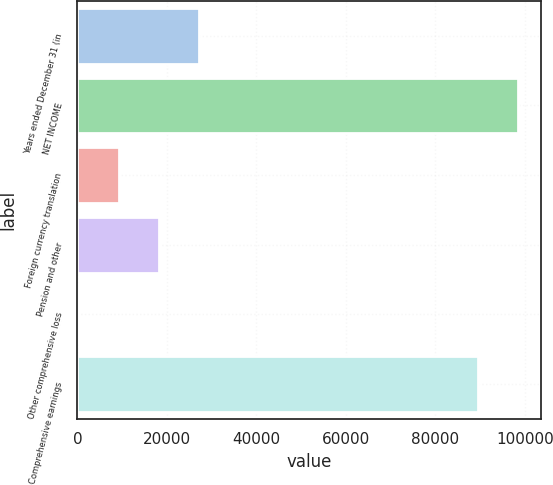<chart> <loc_0><loc_0><loc_500><loc_500><bar_chart><fcel>Years ended December 31 (in<fcel>NET INCOME<fcel>Foreign currency translation<fcel>Pension and other<fcel>Other comprehensive loss<fcel>Comprehensive earnings<nl><fcel>27254.7<fcel>98602.9<fcel>9326.9<fcel>18290.8<fcel>363<fcel>89639<nl></chart> 